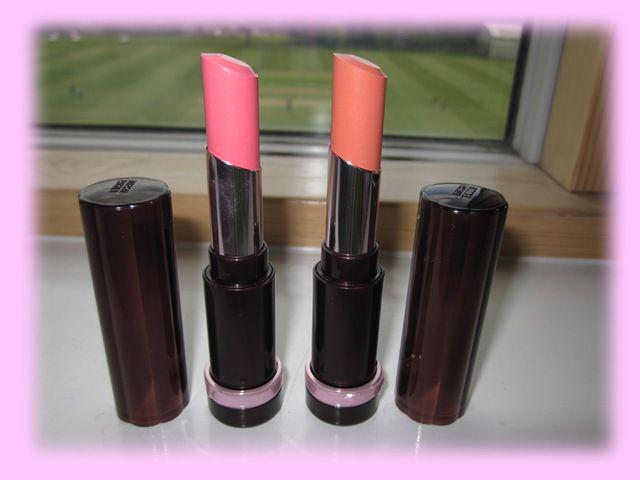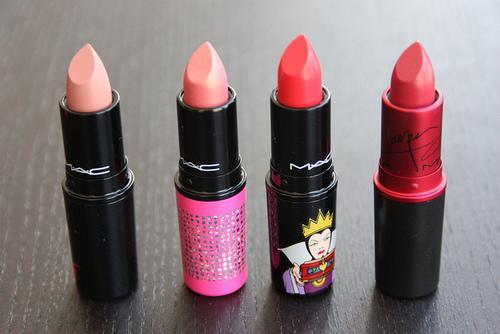The first image is the image on the left, the second image is the image on the right. Considering the images on both sides, is "One image shows two rows of lipsticks, with a rectangular box in front of them." valid? Answer yes or no. No. The first image is the image on the left, the second image is the image on the right. Given the left and right images, does the statement "There is one box in the image on the left." hold true? Answer yes or no. No. 